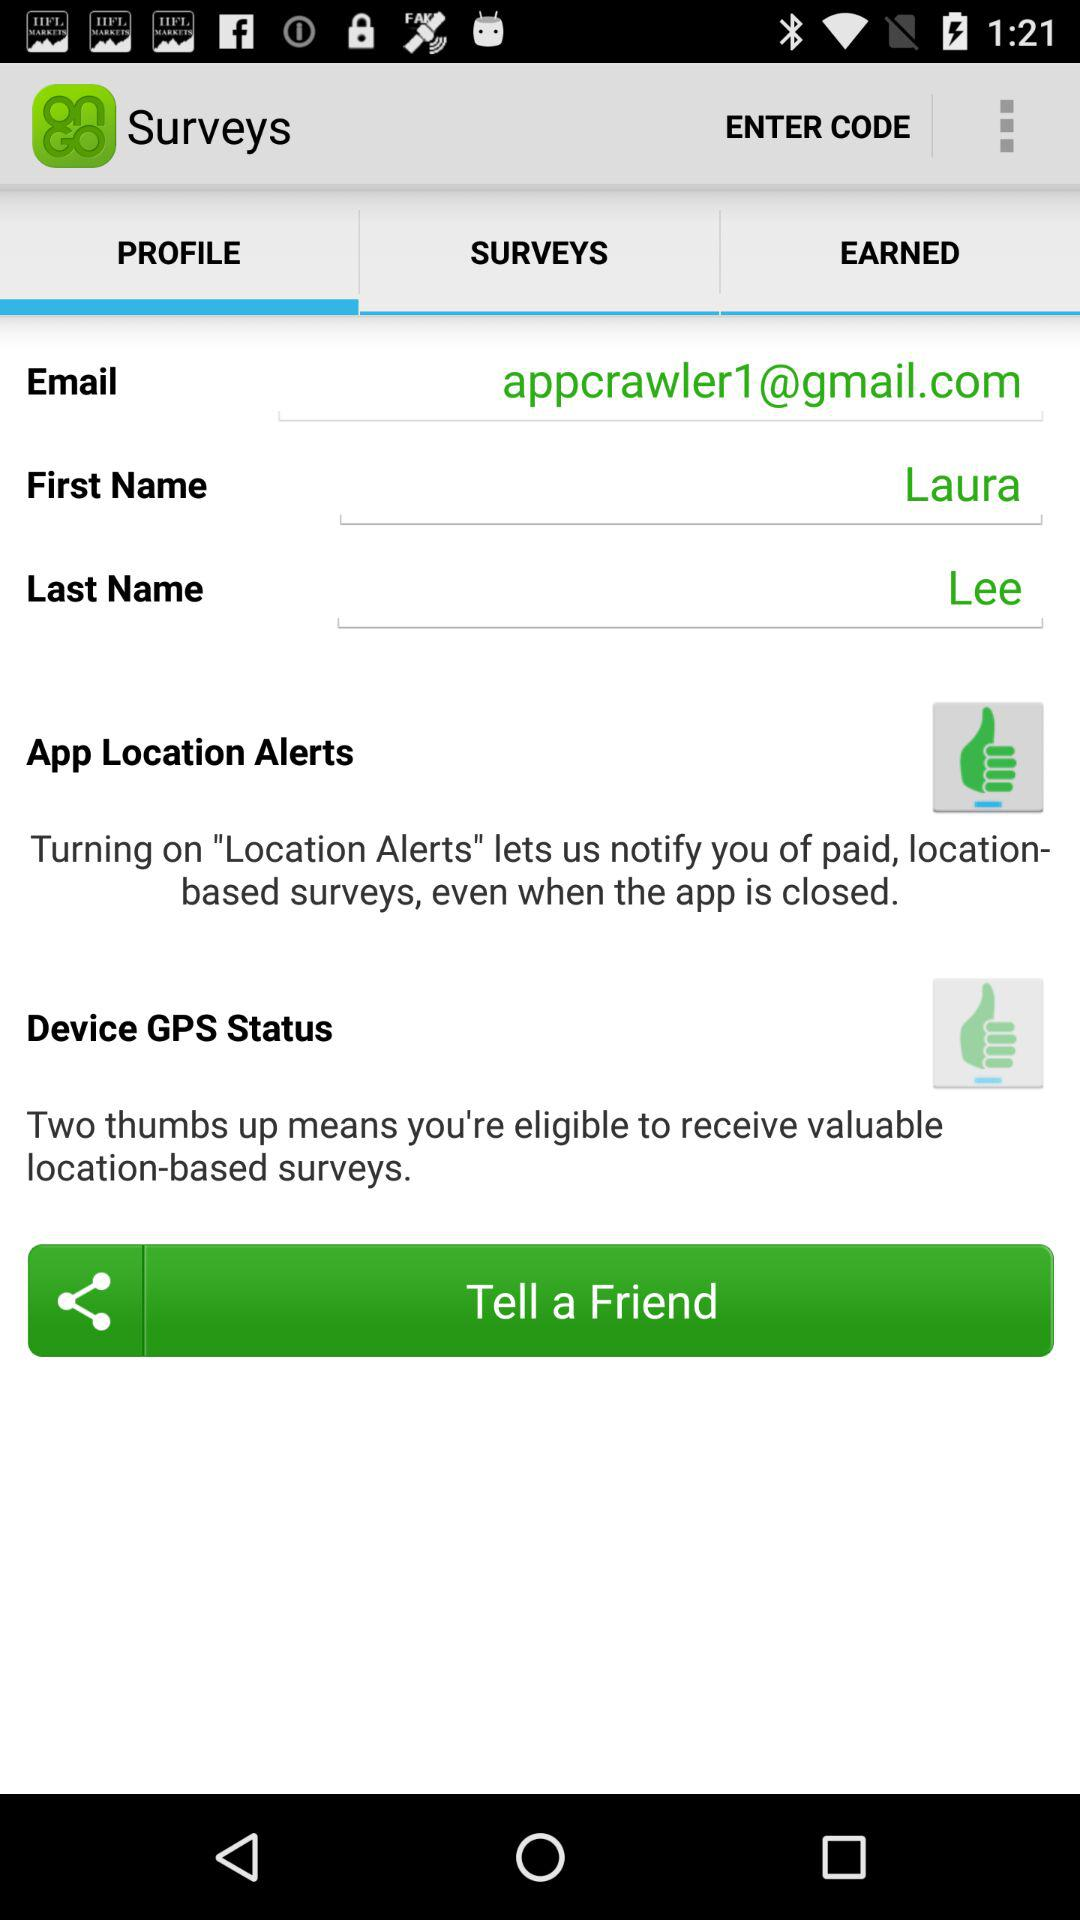What is the selected option? The selected option is "PROFILE". 